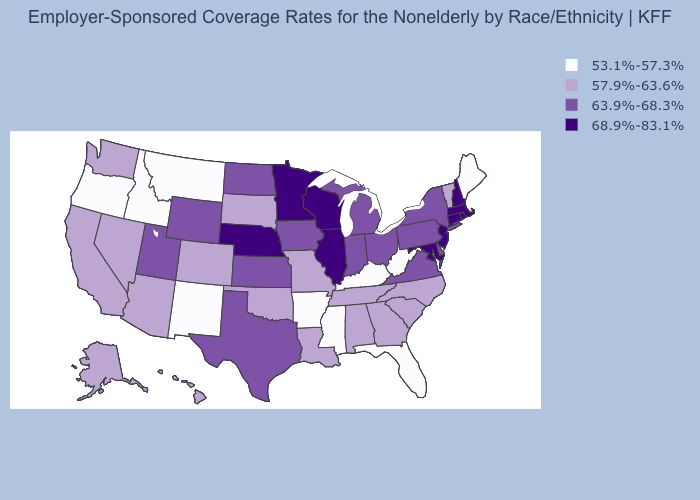What is the highest value in the USA?
Quick response, please. 68.9%-83.1%. Name the states that have a value in the range 53.1%-57.3%?
Concise answer only. Arkansas, Florida, Idaho, Kentucky, Maine, Mississippi, Montana, New Mexico, Oregon, West Virginia. What is the value of Montana?
Concise answer only. 53.1%-57.3%. Name the states that have a value in the range 57.9%-63.6%?
Keep it brief. Alabama, Alaska, Arizona, California, Colorado, Georgia, Hawaii, Louisiana, Missouri, Nevada, North Carolina, Oklahoma, South Carolina, South Dakota, Tennessee, Vermont, Washington. Among the states that border Minnesota , which have the lowest value?
Be succinct. South Dakota. What is the value of Alaska?
Answer briefly. 57.9%-63.6%. What is the value of South Dakota?
Keep it brief. 57.9%-63.6%. Name the states that have a value in the range 53.1%-57.3%?
Keep it brief. Arkansas, Florida, Idaho, Kentucky, Maine, Mississippi, Montana, New Mexico, Oregon, West Virginia. What is the highest value in the MidWest ?
Concise answer only. 68.9%-83.1%. Which states hav the highest value in the Northeast?
Concise answer only. Connecticut, Massachusetts, New Hampshire, New Jersey, Rhode Island. Does the first symbol in the legend represent the smallest category?
Give a very brief answer. Yes. Name the states that have a value in the range 68.9%-83.1%?
Answer briefly. Connecticut, Illinois, Maryland, Massachusetts, Minnesota, Nebraska, New Hampshire, New Jersey, Rhode Island, Wisconsin. What is the value of Iowa?
Write a very short answer. 63.9%-68.3%. Which states have the highest value in the USA?
Short answer required. Connecticut, Illinois, Maryland, Massachusetts, Minnesota, Nebraska, New Hampshire, New Jersey, Rhode Island, Wisconsin. What is the value of Florida?
Answer briefly. 53.1%-57.3%. 